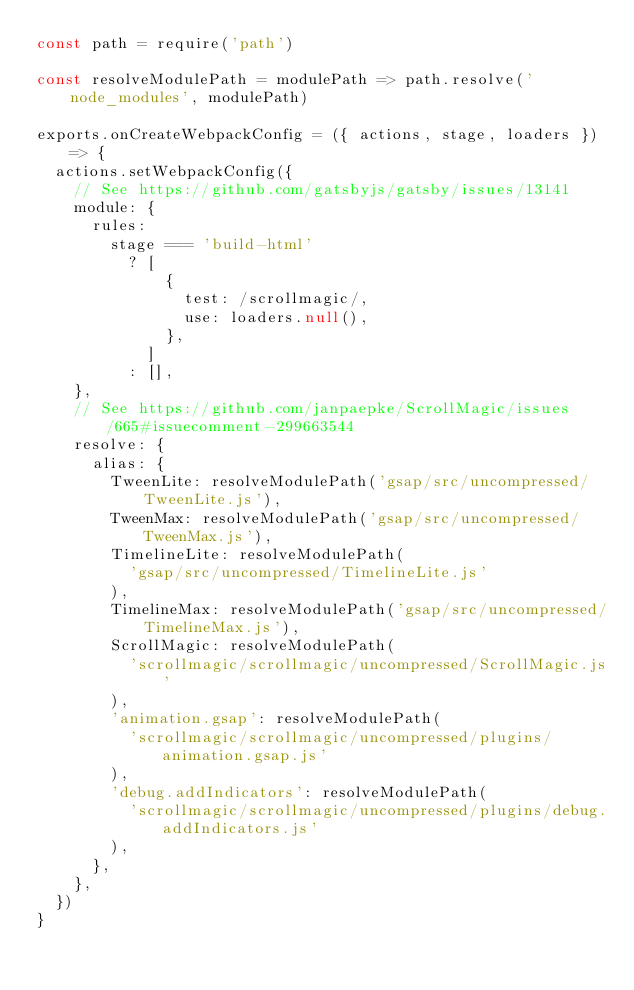Convert code to text. <code><loc_0><loc_0><loc_500><loc_500><_JavaScript_>const path = require('path')

const resolveModulePath = modulePath => path.resolve('node_modules', modulePath)

exports.onCreateWebpackConfig = ({ actions, stage, loaders }) => {
  actions.setWebpackConfig({
    // See https://github.com/gatsbyjs/gatsby/issues/13141
    module: {
      rules:
        stage === 'build-html'
          ? [
              {
                test: /scrollmagic/,
                use: loaders.null(),
              },
            ]
          : [],
    },
    // See https://github.com/janpaepke/ScrollMagic/issues/665#issuecomment-299663544
    resolve: {
      alias: {
        TweenLite: resolveModulePath('gsap/src/uncompressed/TweenLite.js'),
        TweenMax: resolveModulePath('gsap/src/uncompressed/TweenMax.js'),
        TimelineLite: resolveModulePath(
          'gsap/src/uncompressed/TimelineLite.js'
        ),
        TimelineMax: resolveModulePath('gsap/src/uncompressed/TimelineMax.js'),
        ScrollMagic: resolveModulePath(
          'scrollmagic/scrollmagic/uncompressed/ScrollMagic.js'
        ),
        'animation.gsap': resolveModulePath(
          'scrollmagic/scrollmagic/uncompressed/plugins/animation.gsap.js'
        ),
        'debug.addIndicators': resolveModulePath(
          'scrollmagic/scrollmagic/uncompressed/plugins/debug.addIndicators.js'
        ),
      },
    },
  })
}
</code> 